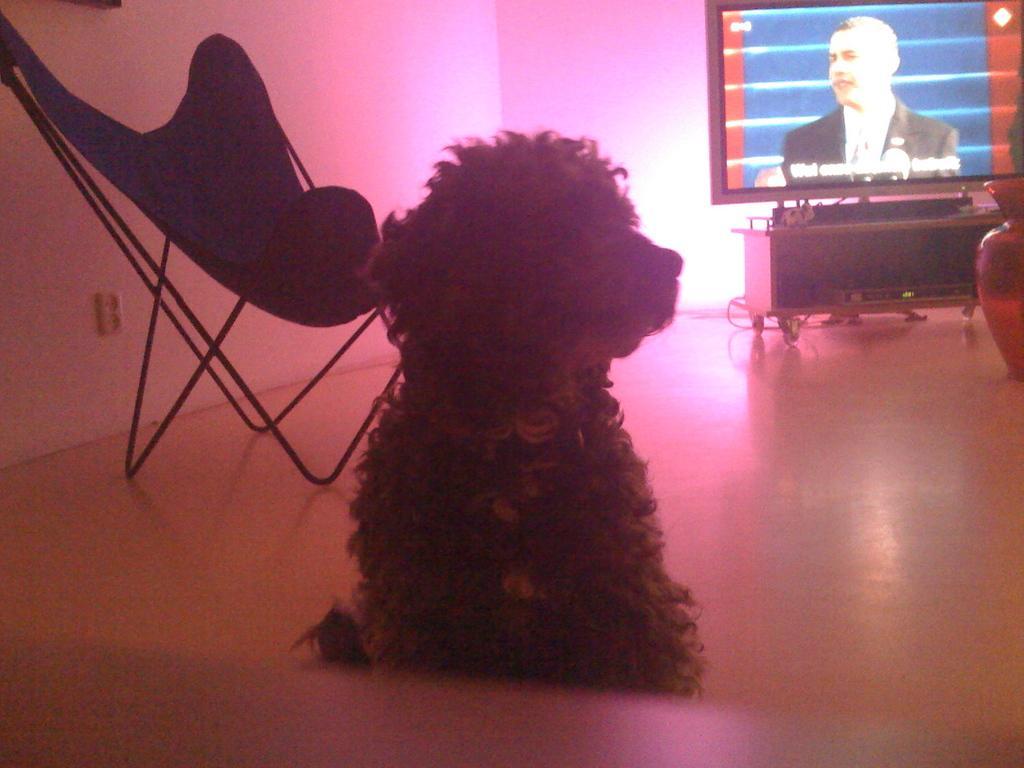Could you give a brief overview of what you see in this image? In this image I can see in the middle it looks like a dog. On the right side there is television, on the left side there is the chair. 